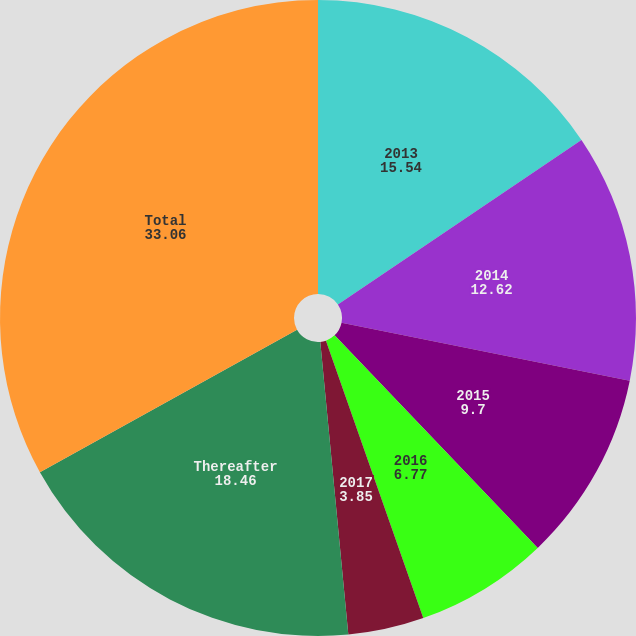Convert chart to OTSL. <chart><loc_0><loc_0><loc_500><loc_500><pie_chart><fcel>2013<fcel>2014<fcel>2015<fcel>2016<fcel>2017<fcel>Thereafter<fcel>Total<nl><fcel>15.54%<fcel>12.62%<fcel>9.7%<fcel>6.77%<fcel>3.85%<fcel>18.46%<fcel>33.06%<nl></chart> 